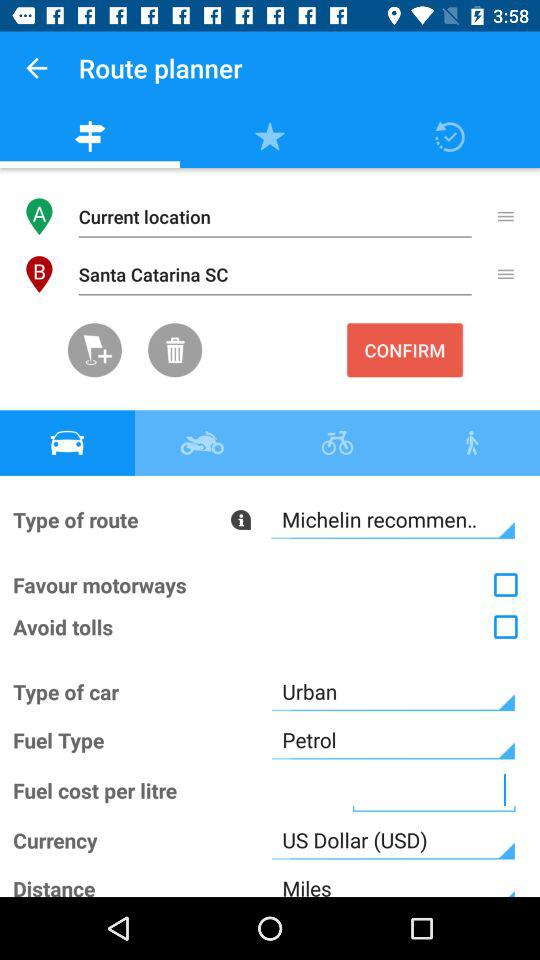What is the unit of distance in the application? The unit of distance in the application is "Miles". 